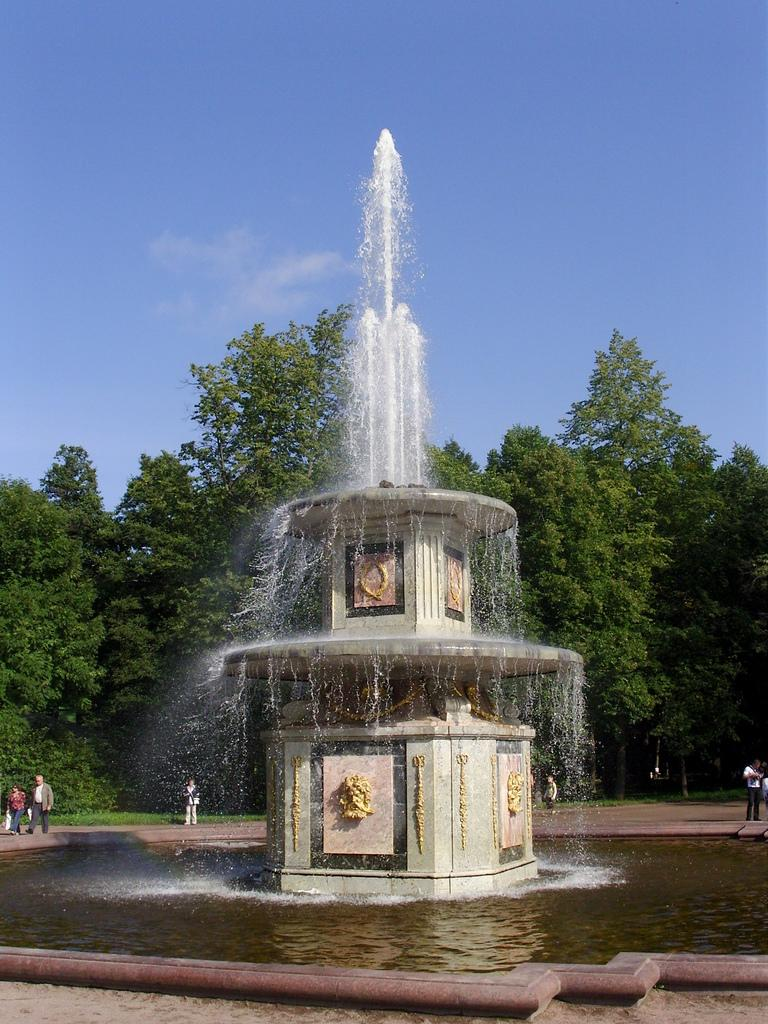What is the main feature in the image? There is a water fountain in the image. Are there any people present in the image? Yes, there are people in the image. What other natural elements can be seen in the image? There are trees in the image. What can be seen in the background of the image? The sky is visible in the background of the image. What type of scarf is being used by the cows in the image? There are no cows or scarves present in the image. What type of amusement can be seen in the image? There is no amusement park or ride visible in the image; it features a water fountain, people, trees, and the sky. 